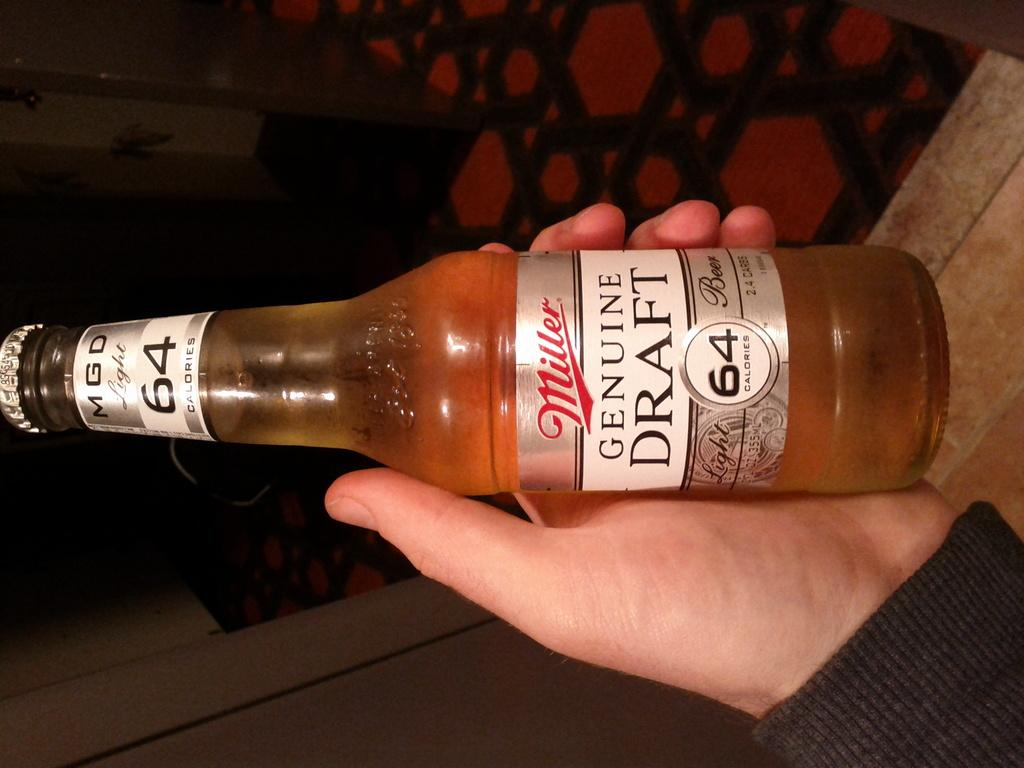<image>
Write a terse but informative summary of the picture. Someone holds a bottle of Miller Genuine Draft light 64. 